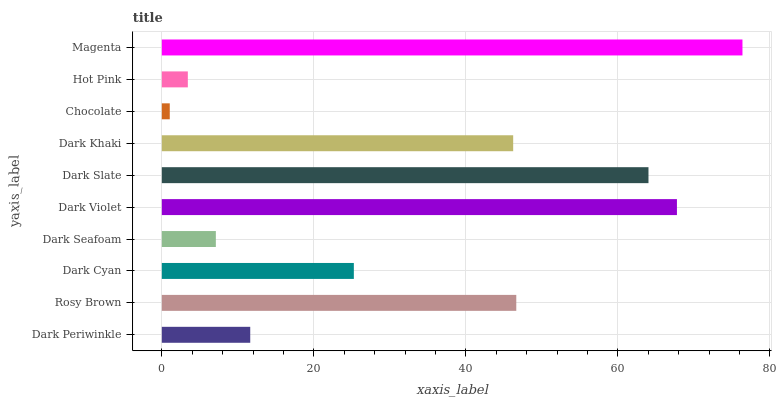Is Chocolate the minimum?
Answer yes or no. Yes. Is Magenta the maximum?
Answer yes or no. Yes. Is Rosy Brown the minimum?
Answer yes or no. No. Is Rosy Brown the maximum?
Answer yes or no. No. Is Rosy Brown greater than Dark Periwinkle?
Answer yes or no. Yes. Is Dark Periwinkle less than Rosy Brown?
Answer yes or no. Yes. Is Dark Periwinkle greater than Rosy Brown?
Answer yes or no. No. Is Rosy Brown less than Dark Periwinkle?
Answer yes or no. No. Is Dark Khaki the high median?
Answer yes or no. Yes. Is Dark Cyan the low median?
Answer yes or no. Yes. Is Dark Seafoam the high median?
Answer yes or no. No. Is Dark Slate the low median?
Answer yes or no. No. 